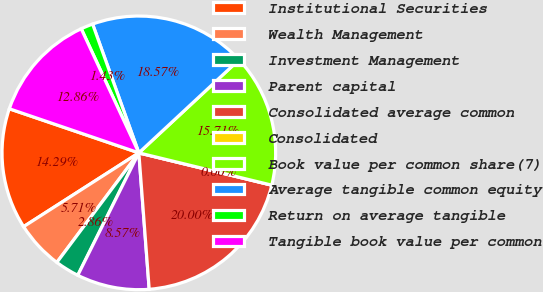Convert chart to OTSL. <chart><loc_0><loc_0><loc_500><loc_500><pie_chart><fcel>Institutional Securities<fcel>Wealth Management<fcel>Investment Management<fcel>Parent capital<fcel>Consolidated average common<fcel>Consolidated<fcel>Book value per common share(7)<fcel>Average tangible common equity<fcel>Return on average tangible<fcel>Tangible book value per common<nl><fcel>14.29%<fcel>5.71%<fcel>2.86%<fcel>8.57%<fcel>20.0%<fcel>0.0%<fcel>15.71%<fcel>18.57%<fcel>1.43%<fcel>12.86%<nl></chart> 